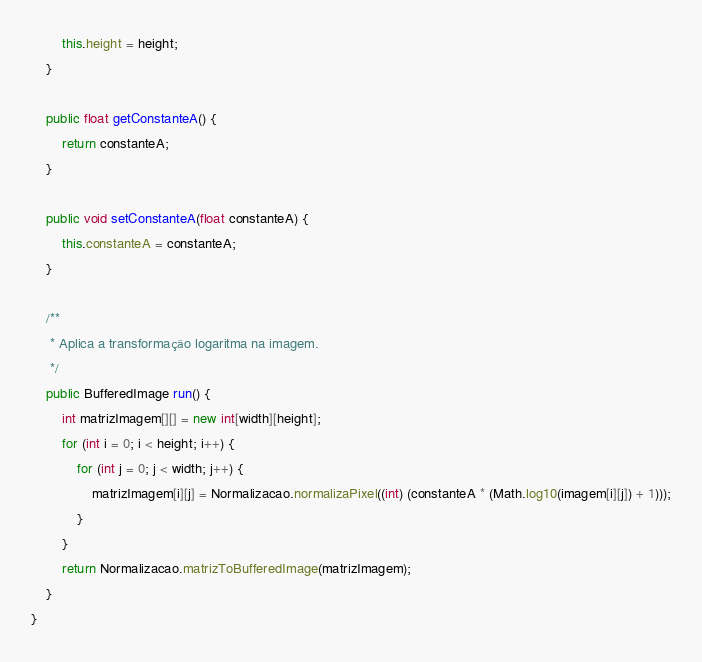<code> <loc_0><loc_0><loc_500><loc_500><_Java_>        this.height = height;
    }

    public float getConstanteA() {
        return constanteA;
    }

    public void setConstanteA(float constanteA) {
        this.constanteA = constanteA;
    }

    /**
     * Aplica a transformação logaritma na imagem.
     */
    public BufferedImage run() {
        int matrizImagem[][] = new int[width][height];
        for (int i = 0; i < height; i++) {
            for (int j = 0; j < width; j++) {
                matrizImagem[i][j] = Normalizacao.normalizaPixel((int) (constanteA * (Math.log10(imagem[i][j]) + 1)));
            }
        }
        return Normalizacao.matrizToBufferedImage(matrizImagem);
    }
}</code> 